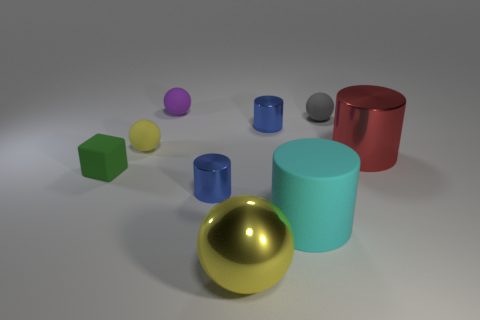Do the large rubber thing and the small matte thing on the right side of the big yellow metal sphere have the same shape?
Offer a terse response. No. Is there a purple sphere?
Provide a short and direct response. Yes. What number of small things are either shiny cylinders or yellow rubber objects?
Offer a very short reply. 3. Is the number of tiny blue cylinders on the right side of the small gray matte thing greater than the number of tiny matte things that are to the left of the tiny yellow thing?
Keep it short and to the point. No. Is the red cylinder made of the same material as the cyan thing right of the yellow rubber ball?
Your answer should be compact. No. What is the color of the block?
Ensure brevity in your answer.  Green. There is a yellow thing that is in front of the tiny green cube; what is its shape?
Ensure brevity in your answer.  Sphere. How many cyan objects are big metallic cylinders or large matte objects?
Your response must be concise. 1. What is the color of the block that is the same material as the purple thing?
Keep it short and to the point. Green. Do the big rubber cylinder and the small metallic cylinder that is behind the red cylinder have the same color?
Give a very brief answer. No. 